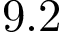Convert formula to latex. <formula><loc_0><loc_0><loc_500><loc_500>9 . 2</formula> 